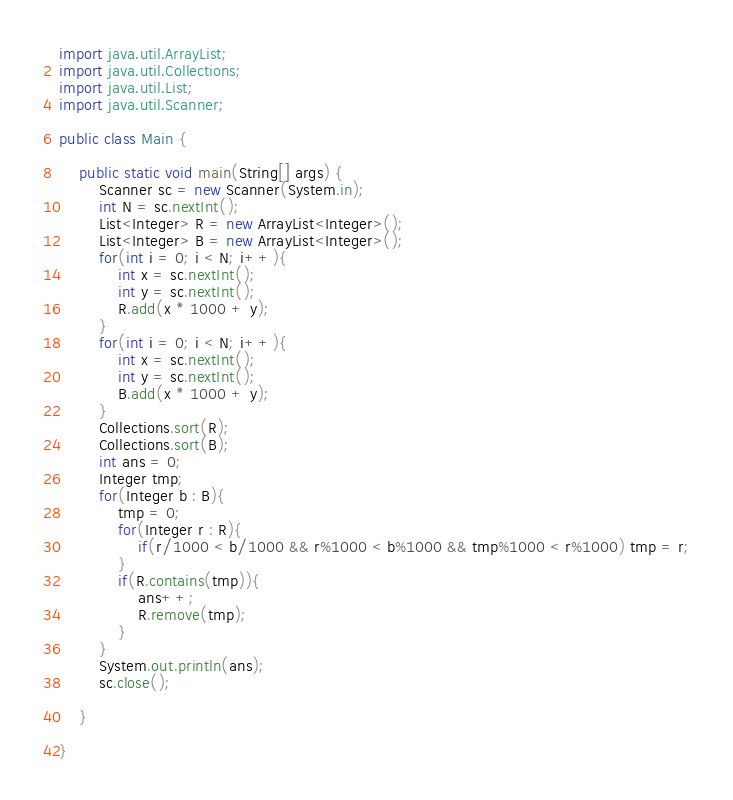<code> <loc_0><loc_0><loc_500><loc_500><_Java_>import java.util.ArrayList;
import java.util.Collections;
import java.util.List;
import java.util.Scanner;

public class Main {

    public static void main(String[] args) {
        Scanner sc = new Scanner(System.in);
        int N = sc.nextInt();
        List<Integer> R = new ArrayList<Integer>();
        List<Integer> B = new ArrayList<Integer>();
        for(int i = 0; i < N; i++){
            int x = sc.nextInt();
            int y = sc.nextInt();
            R.add(x * 1000 + y);
        }
        for(int i = 0; i < N; i++){
            int x = sc.nextInt();
            int y = sc.nextInt();
            B.add(x * 1000 + y);
        }
        Collections.sort(R);
        Collections.sort(B);
        int ans = 0;
        Integer tmp;
        for(Integer b : B){
            tmp = 0;
            for(Integer r : R){
                if(r/1000 < b/1000 && r%1000 < b%1000 && tmp%1000 < r%1000) tmp = r;
            }
            if(R.contains(tmp)){
                ans++;
                R.remove(tmp);
            }
        }
        System.out.println(ans);
        sc.close();

    }

}
</code> 